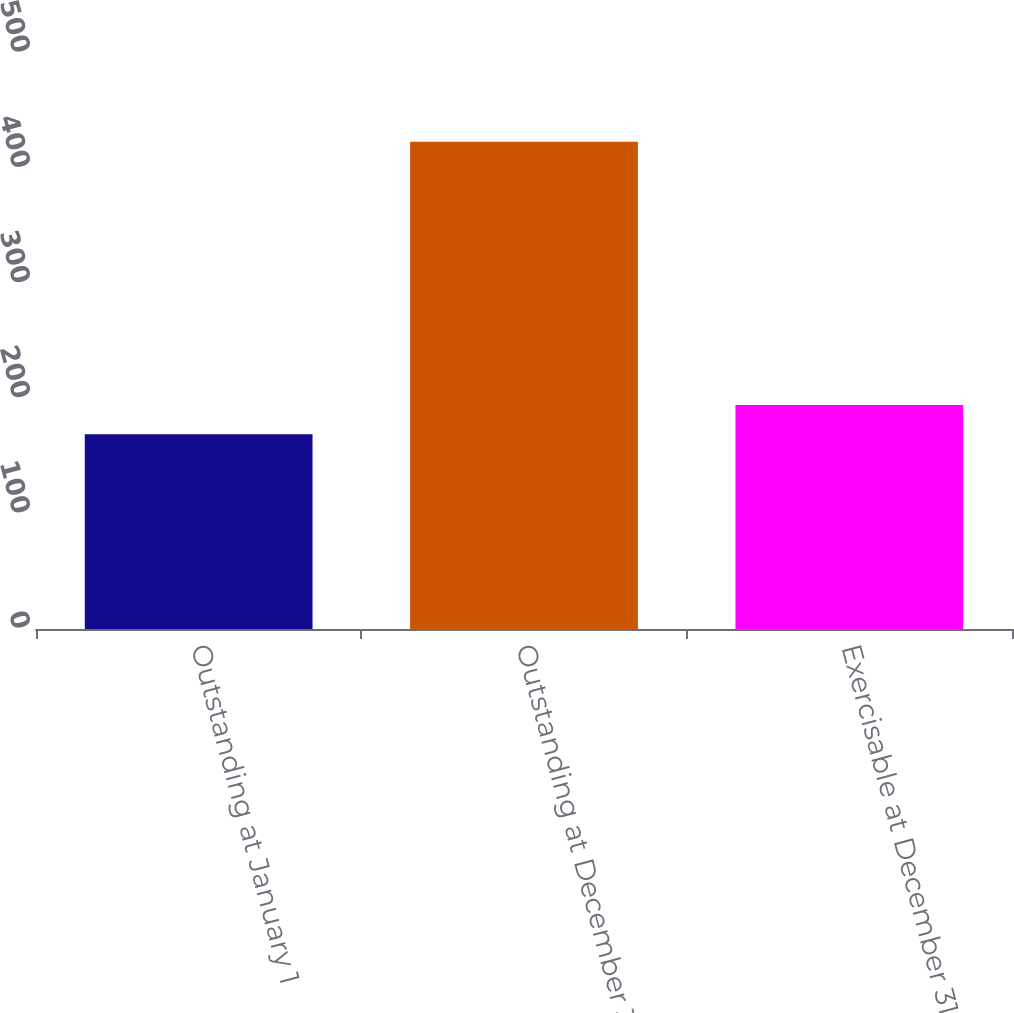Convert chart to OTSL. <chart><loc_0><loc_0><loc_500><loc_500><bar_chart><fcel>Outstanding at January 1<fcel>Outstanding at December 31<fcel>Exercisable at December 31<nl><fcel>169<fcel>423<fcel>194.4<nl></chart> 